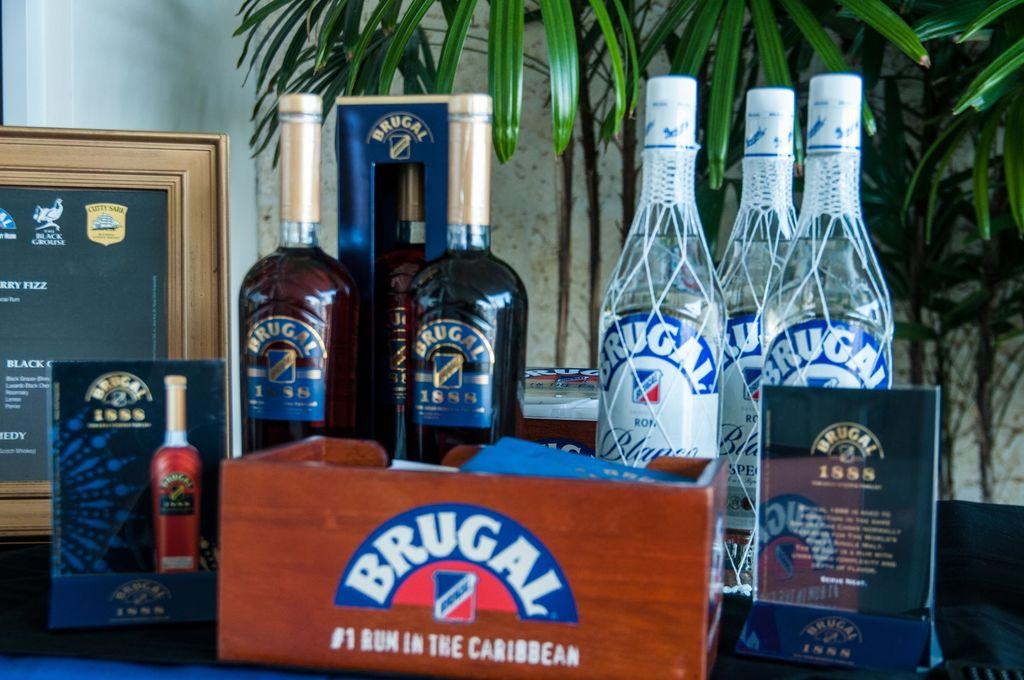<image>
Create a compact narrative representing the image presented. Several bottles of Brugal rum are on display. 